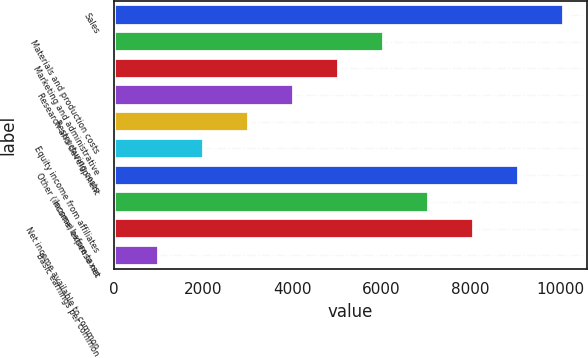Convert chart to OTSL. <chart><loc_0><loc_0><loc_500><loc_500><bar_chart><fcel>Sales<fcel>Materials and production costs<fcel>Marketing and administrative<fcel>Research and development<fcel>Restructuring costs<fcel>Equity income from affiliates<fcel>Other (income) expense net<fcel>Income before taxes<fcel>Net income available to common<fcel>Basic earnings per common<nl><fcel>10093.5<fcel>6057.05<fcel>5047.93<fcel>4038.81<fcel>3029.7<fcel>2020.59<fcel>9084.39<fcel>7066.16<fcel>8075.27<fcel>1011.47<nl></chart> 